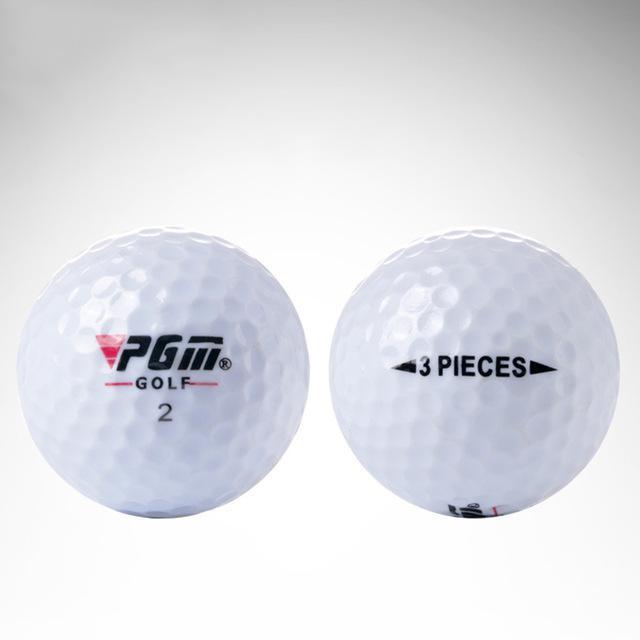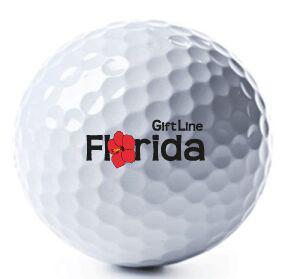The first image is the image on the left, the second image is the image on the right. Examine the images to the left and right. Is the description "The left and right image contains a total of four golf balls." accurate? Answer yes or no. No. 